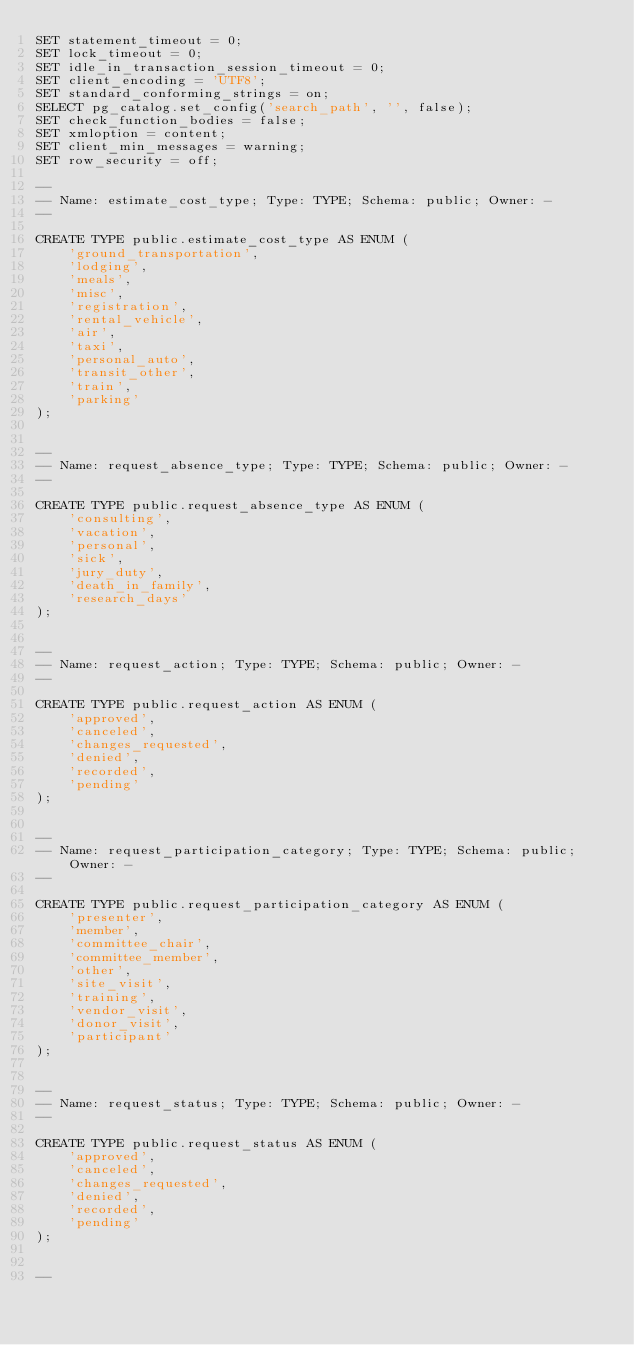<code> <loc_0><loc_0><loc_500><loc_500><_SQL_>SET statement_timeout = 0;
SET lock_timeout = 0;
SET idle_in_transaction_session_timeout = 0;
SET client_encoding = 'UTF8';
SET standard_conforming_strings = on;
SELECT pg_catalog.set_config('search_path', '', false);
SET check_function_bodies = false;
SET xmloption = content;
SET client_min_messages = warning;
SET row_security = off;

--
-- Name: estimate_cost_type; Type: TYPE; Schema: public; Owner: -
--

CREATE TYPE public.estimate_cost_type AS ENUM (
    'ground_transportation',
    'lodging',
    'meals',
    'misc',
    'registration',
    'rental_vehicle',
    'air',
    'taxi',
    'personal_auto',
    'transit_other',
    'train',
    'parking'
);


--
-- Name: request_absence_type; Type: TYPE; Schema: public; Owner: -
--

CREATE TYPE public.request_absence_type AS ENUM (
    'consulting',
    'vacation',
    'personal',
    'sick',
    'jury_duty',
    'death_in_family',
    'research_days'
);


--
-- Name: request_action; Type: TYPE; Schema: public; Owner: -
--

CREATE TYPE public.request_action AS ENUM (
    'approved',
    'canceled',
    'changes_requested',
    'denied',
    'recorded',
    'pending'
);


--
-- Name: request_participation_category; Type: TYPE; Schema: public; Owner: -
--

CREATE TYPE public.request_participation_category AS ENUM (
    'presenter',
    'member',
    'committee_chair',
    'committee_member',
    'other',
    'site_visit',
    'training',
    'vendor_visit',
    'donor_visit',
    'participant'
);


--
-- Name: request_status; Type: TYPE; Schema: public; Owner: -
--

CREATE TYPE public.request_status AS ENUM (
    'approved',
    'canceled',
    'changes_requested',
    'denied',
    'recorded',
    'pending'
);


--</code> 